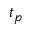Convert formula to latex. <formula><loc_0><loc_0><loc_500><loc_500>t _ { p }</formula> 